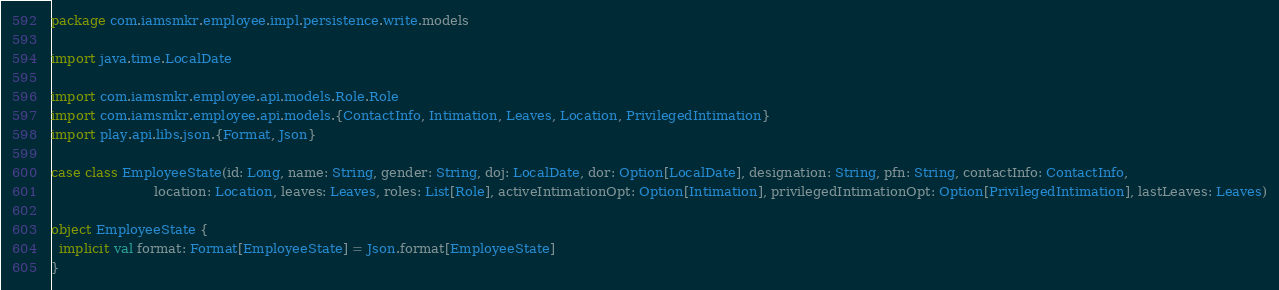Convert code to text. <code><loc_0><loc_0><loc_500><loc_500><_Scala_>package com.iamsmkr.employee.impl.persistence.write.models

import java.time.LocalDate

import com.iamsmkr.employee.api.models.Role.Role
import com.iamsmkr.employee.api.models.{ContactInfo, Intimation, Leaves, Location, PrivilegedIntimation}
import play.api.libs.json.{Format, Json}

case class EmployeeState(id: Long, name: String, gender: String, doj: LocalDate, dor: Option[LocalDate], designation: String, pfn: String, contactInfo: ContactInfo,
                         location: Location, leaves: Leaves, roles: List[Role], activeIntimationOpt: Option[Intimation], privilegedIntimationOpt: Option[PrivilegedIntimation], lastLeaves: Leaves)

object EmployeeState {
  implicit val format: Format[EmployeeState] = Json.format[EmployeeState]
}
</code> 